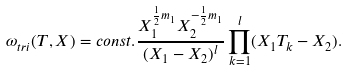Convert formula to latex. <formula><loc_0><loc_0><loc_500><loc_500>\omega _ { t r i } ( T , X ) = c o n s t . \frac { X _ { 1 } ^ { \frac { 1 } { 2 } m _ { 1 } } X _ { 2 } ^ { - \frac { 1 } { 2 } m _ { 1 } } } { ( X _ { 1 } - X _ { 2 } ) ^ { l } } \prod _ { k = 1 } ^ { l } ( X _ { 1 } T _ { k } - X _ { 2 } ) .</formula> 